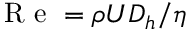<formula> <loc_0><loc_0><loc_500><loc_500>R e = \rho U D _ { h } / \eta</formula> 